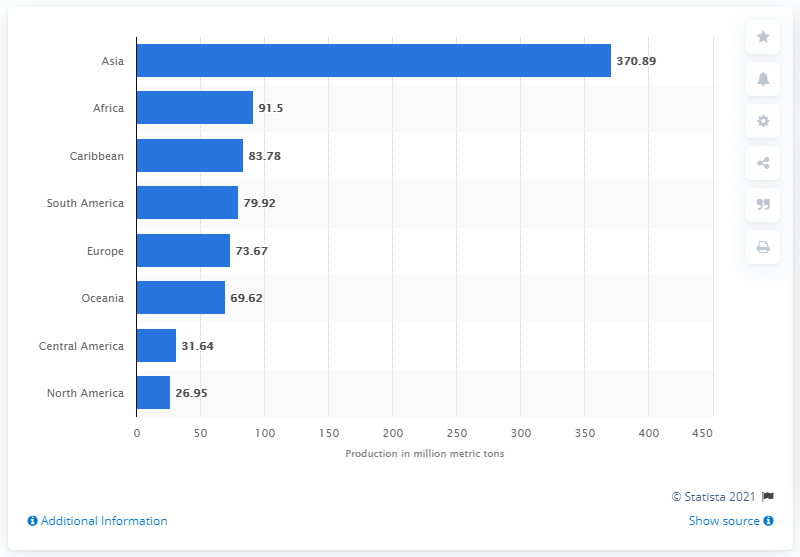Point out several critical features in this image. The leading global fruit supplier is Asia. In 2014, it is estimated that a total of 370.89 million metric tons of fruit was produced in Asia. 